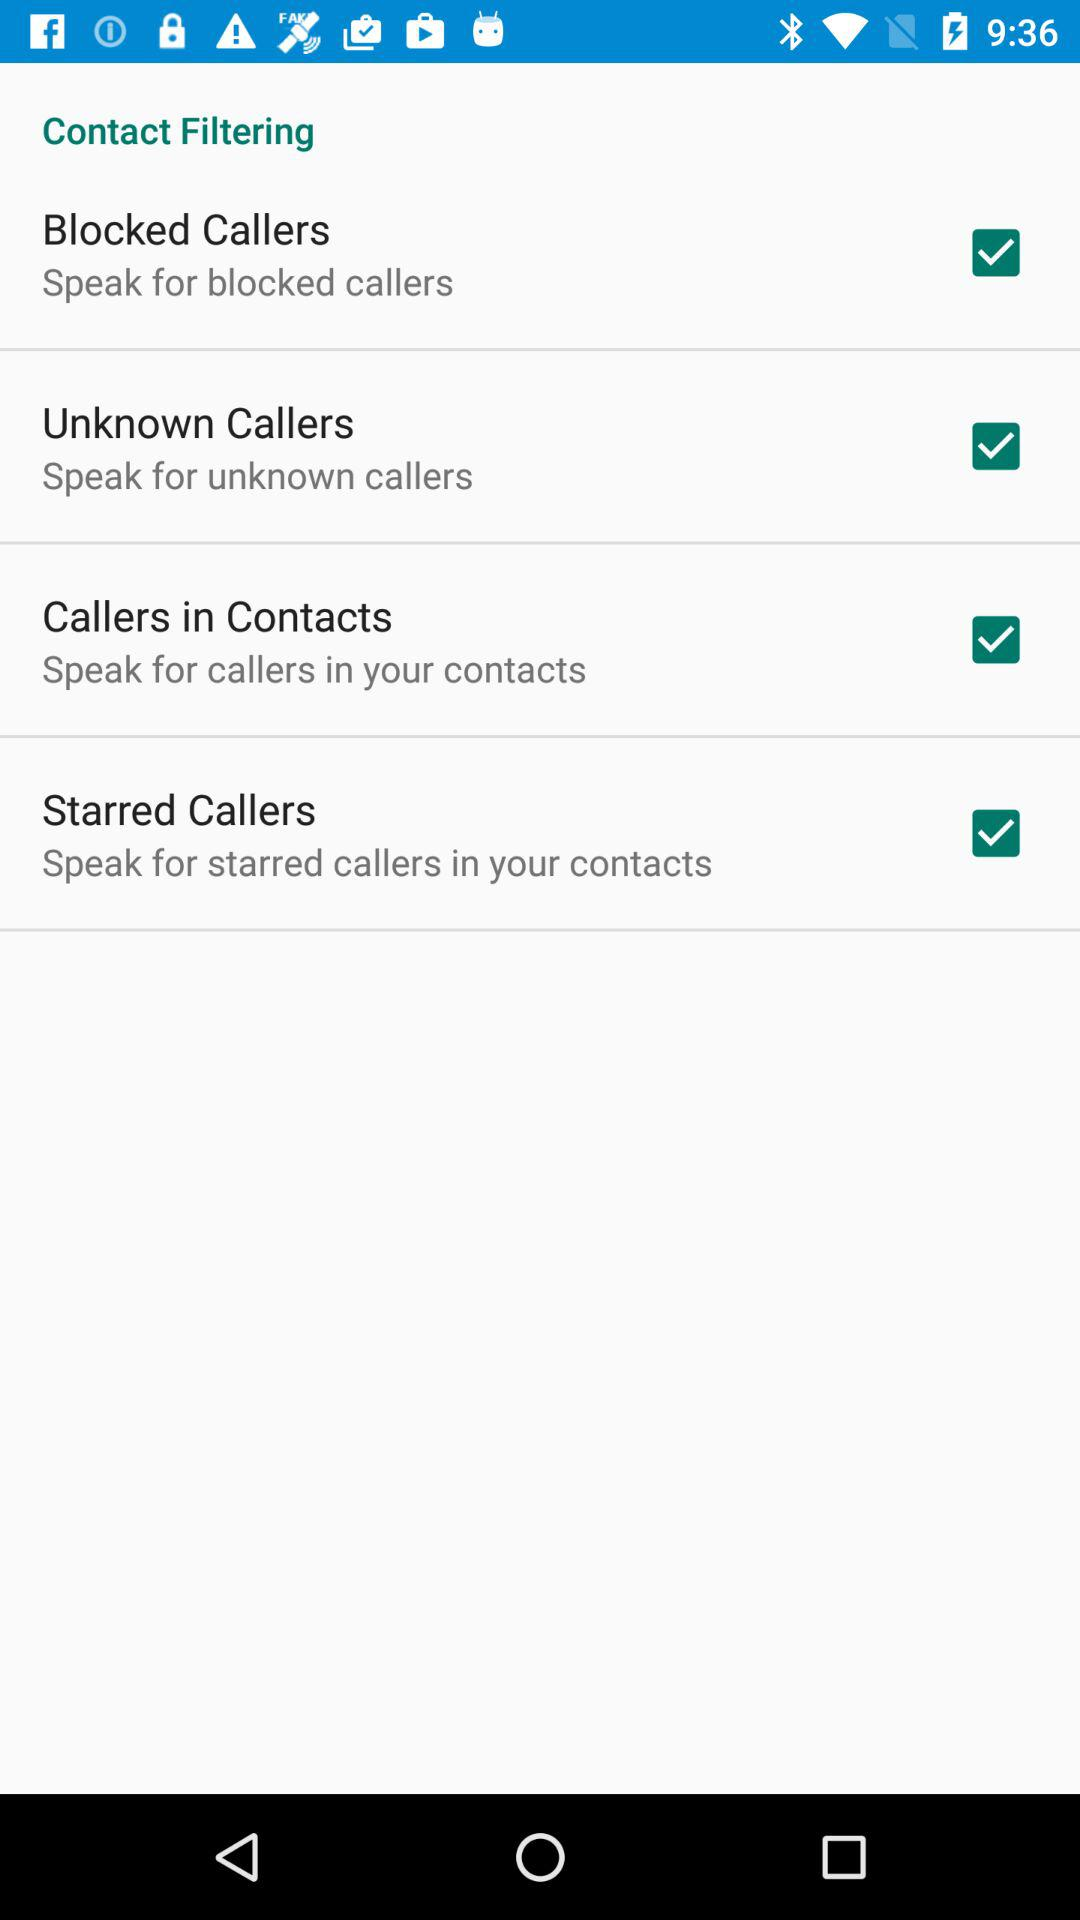How many blocked callers are there?
When the provided information is insufficient, respond with <no answer>. <no answer> 